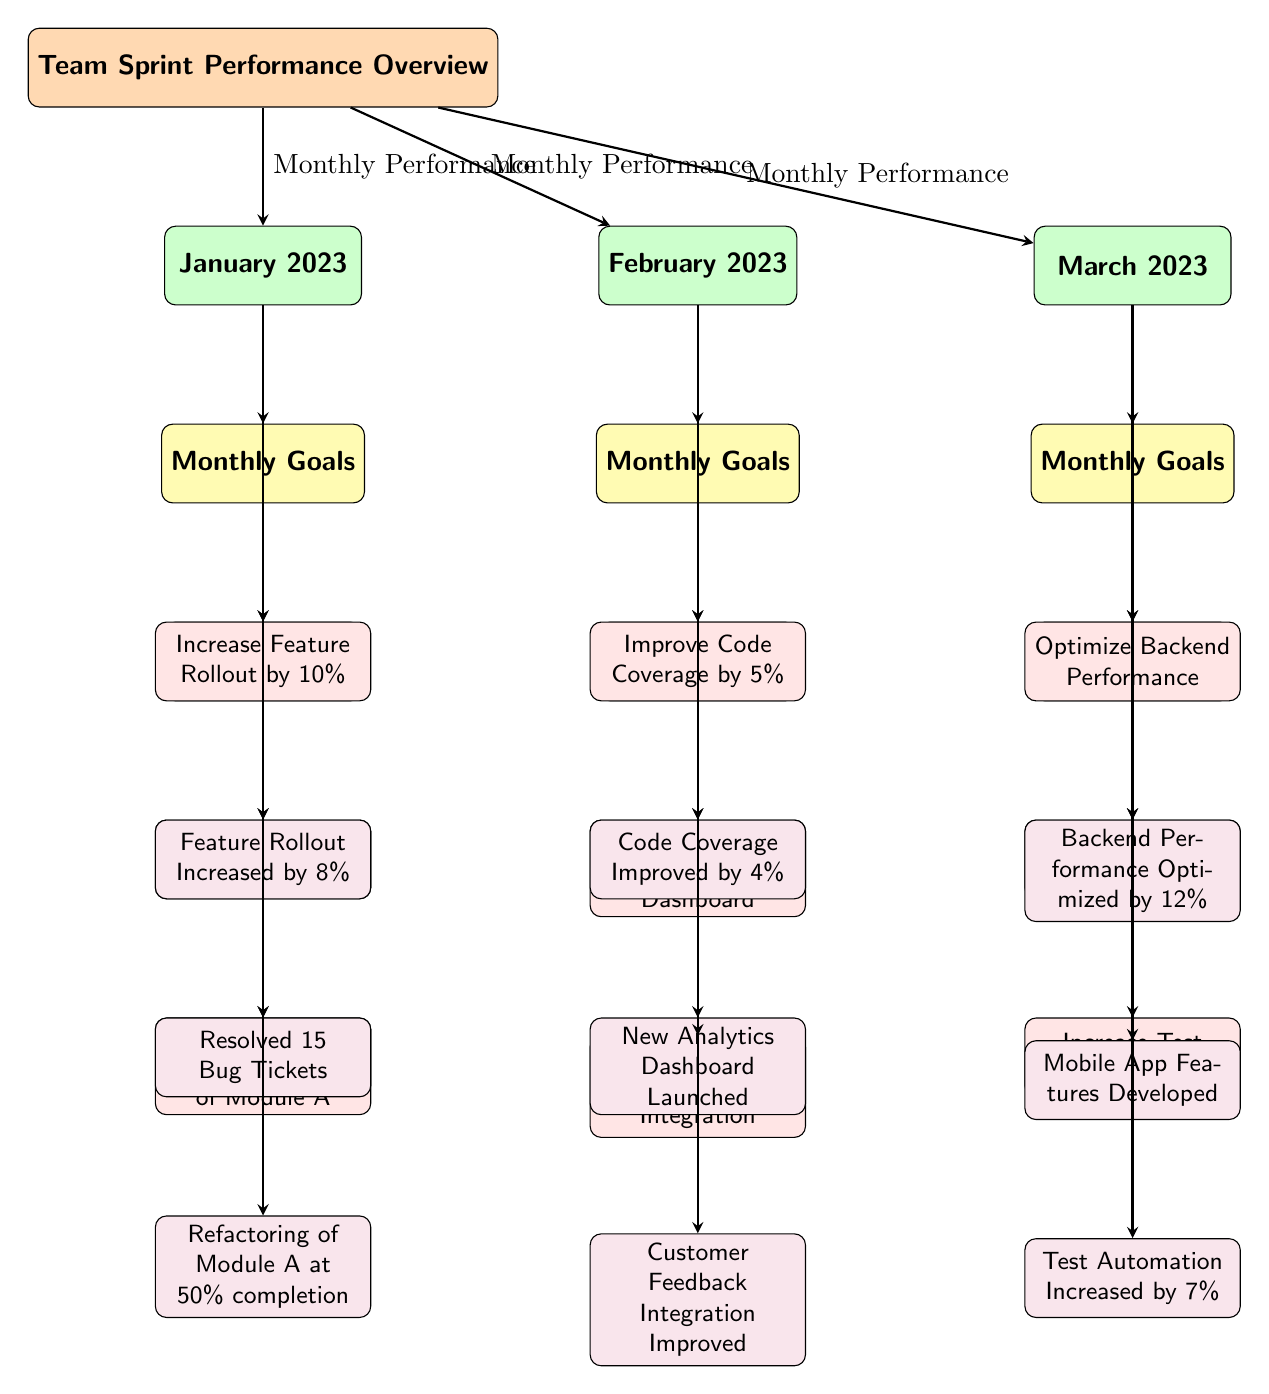What are the goals for January 2023? The diagram lists three goals under the January 2023 category. By looking at the 'Monthly Goals' section for January, we see the following: 'Increase Feature Rollout by 10%', 'Resolve 20 Bug Tickets', and 'Complete Refactoring of Module A'.
Answer: Increase Feature Rollout by 10%, Resolve 20 Bug Tickets, Complete Refactoring of Module A How many achievements are listed for February 2023? Under the 'Achievements' section for February, there are three listed items: 'Code Coverage Improved by 4%', 'New Analytics Dashboard Launched', and 'Customer Feedback Integration Improved'. Therefore, counting those achievements gives us a total of three.
Answer: 3 What percentage did the feature rollout increase in January? The diagram presents the achievement related to feature rollout under January's achievements, indicating, 'Feature Rollout Increased by 8%'. Thus, the increase is specified as 8%.
Answer: 8% Which month achieved a higher percentage of goal completion for backend performance optimization? The relevant data is found in the achievements of March, which says, 'Backend Performance Optimized by 12%', while no similar achievement is listed for January or February. Therefore, the month of March had a higher goal completion percentage for backend performance optimization.
Answer: March What was the main goal for February regarding analytics? Looking at the 'Monthly Goals' for February, one goal is specifically focused on analytics: 'Launch New Analytics Dashboard'. This goal identifies an objective targeted at improving analytics capabilities.
Answer: Launch New Analytics Dashboard How many total monthly performance arrows are shown in the diagram? The diagram illustrates three monthly performance arrows leading from 'Team Sprint Performance Overview' to each of the three months (January, February, and March). There’s one arrow for each month, so the total is three.
Answer: 3 Which month had a goal related to code coverage improvement? By examining the 'Monthly Goals' for February, it states, 'Improve Code Coverage by 5%', clearly indicating that the month with this specific goal is February.
Answer: February What was the completion percentage of test automation by the end of March? The 'Achievements' for March indicates 'Test Automation Increased by 7%', which denotes the completion percentage of the test automation goals pursued during that month.
Answer: 7% 